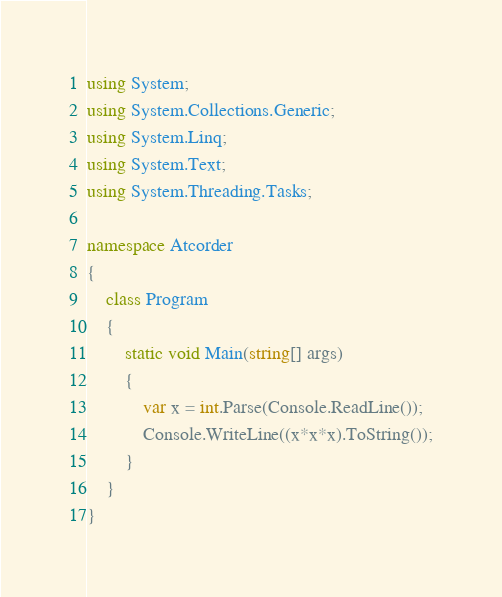Convert code to text. <code><loc_0><loc_0><loc_500><loc_500><_C#_>using System;
using System.Collections.Generic;
using System.Linq;
using System.Text;
using System.Threading.Tasks;

namespace Atcorder
{
    class Program
    {
        static void Main(string[] args)
        {
            var x = int.Parse(Console.ReadLine());
            Console.WriteLine((x*x*x).ToString());
        }
    }
}

</code> 